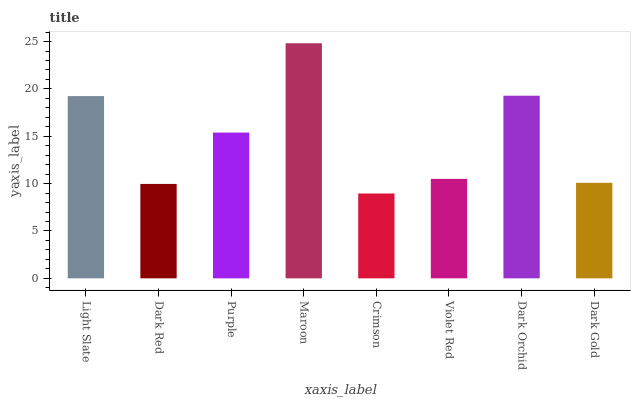Is Crimson the minimum?
Answer yes or no. Yes. Is Maroon the maximum?
Answer yes or no. Yes. Is Dark Red the minimum?
Answer yes or no. No. Is Dark Red the maximum?
Answer yes or no. No. Is Light Slate greater than Dark Red?
Answer yes or no. Yes. Is Dark Red less than Light Slate?
Answer yes or no. Yes. Is Dark Red greater than Light Slate?
Answer yes or no. No. Is Light Slate less than Dark Red?
Answer yes or no. No. Is Purple the high median?
Answer yes or no. Yes. Is Violet Red the low median?
Answer yes or no. Yes. Is Maroon the high median?
Answer yes or no. No. Is Dark Gold the low median?
Answer yes or no. No. 